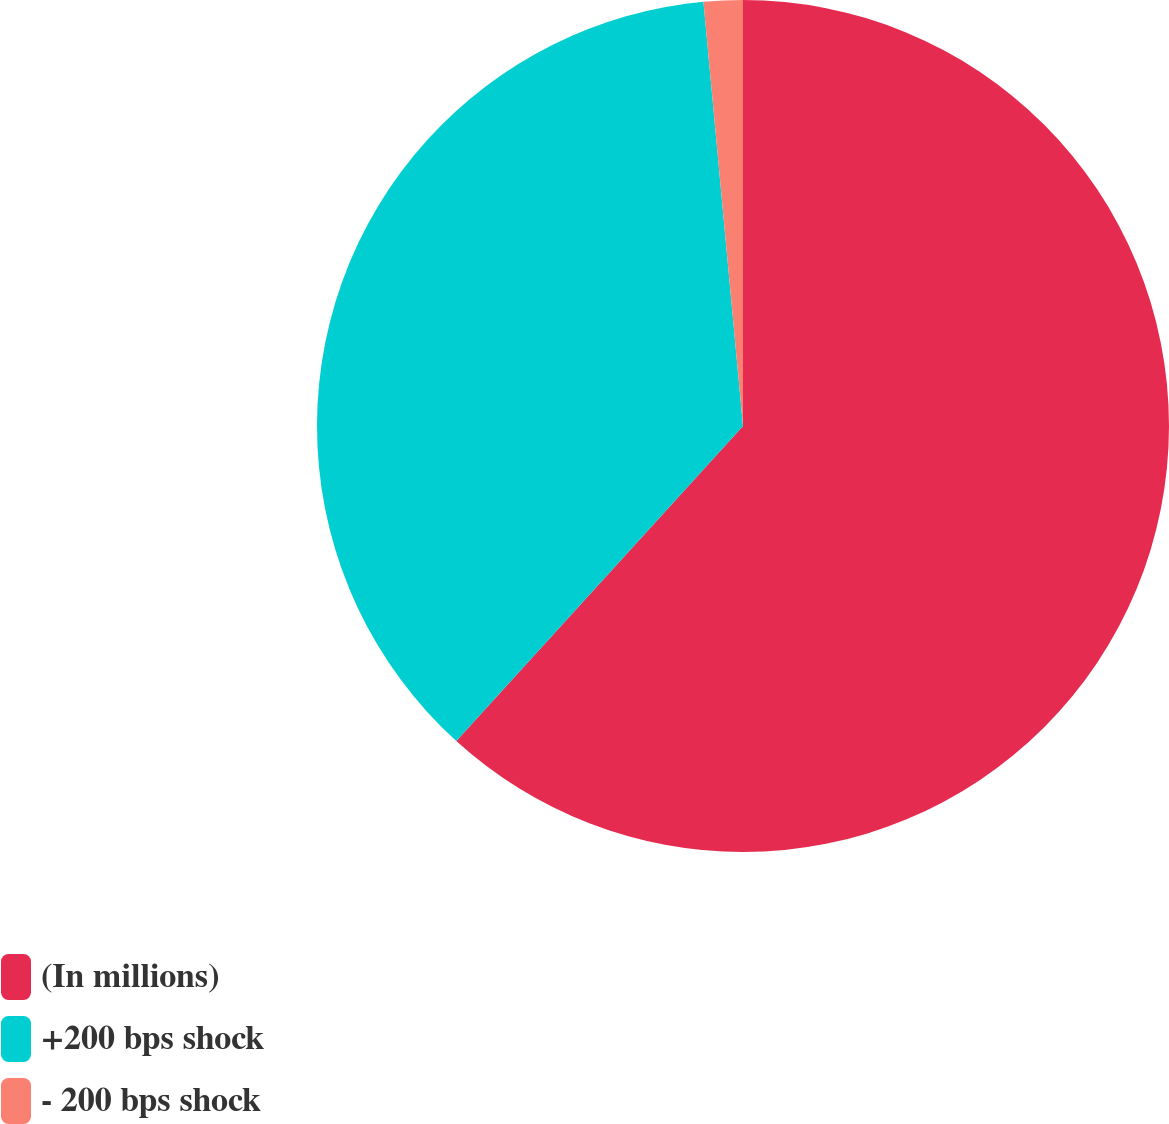<chart> <loc_0><loc_0><loc_500><loc_500><pie_chart><fcel>(In millions)<fcel>+200 bps shock<fcel>- 200 bps shock<nl><fcel>61.75%<fcel>36.77%<fcel>1.48%<nl></chart> 